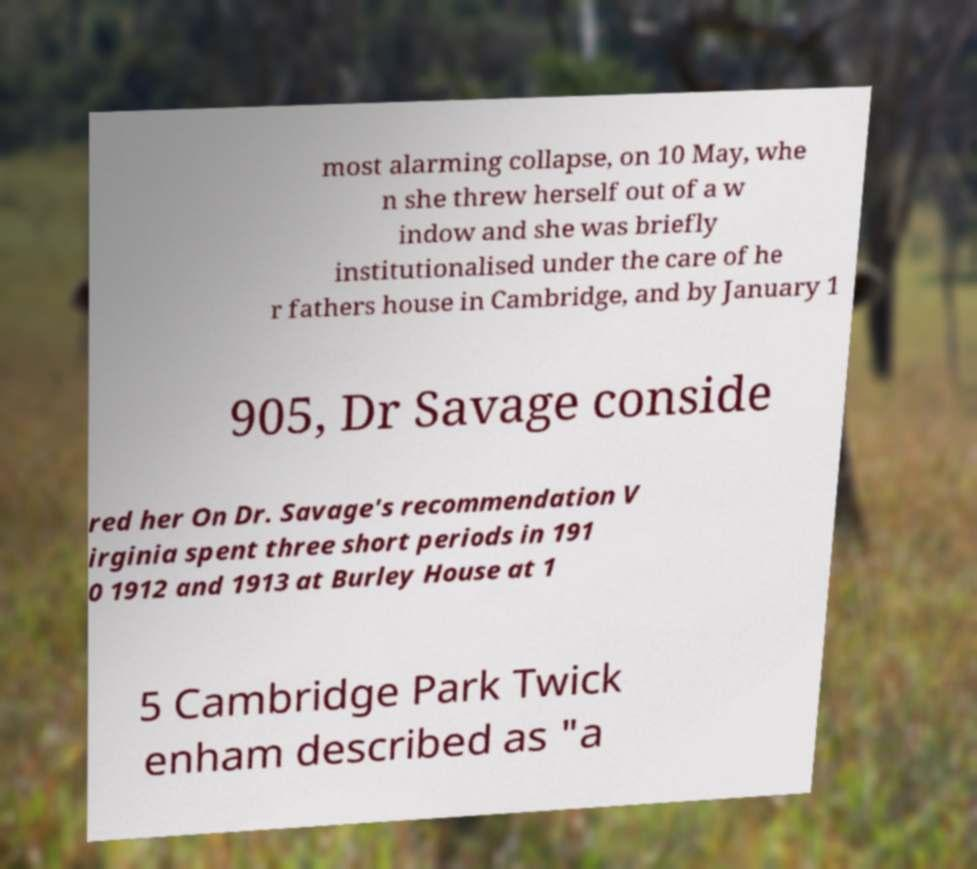What messages or text are displayed in this image? I need them in a readable, typed format. most alarming collapse, on 10 May, whe n she threw herself out of a w indow and she was briefly institutionalised under the care of he r fathers house in Cambridge, and by January 1 905, Dr Savage conside red her On Dr. Savage's recommendation V irginia spent three short periods in 191 0 1912 and 1913 at Burley House at 1 5 Cambridge Park Twick enham described as "a 